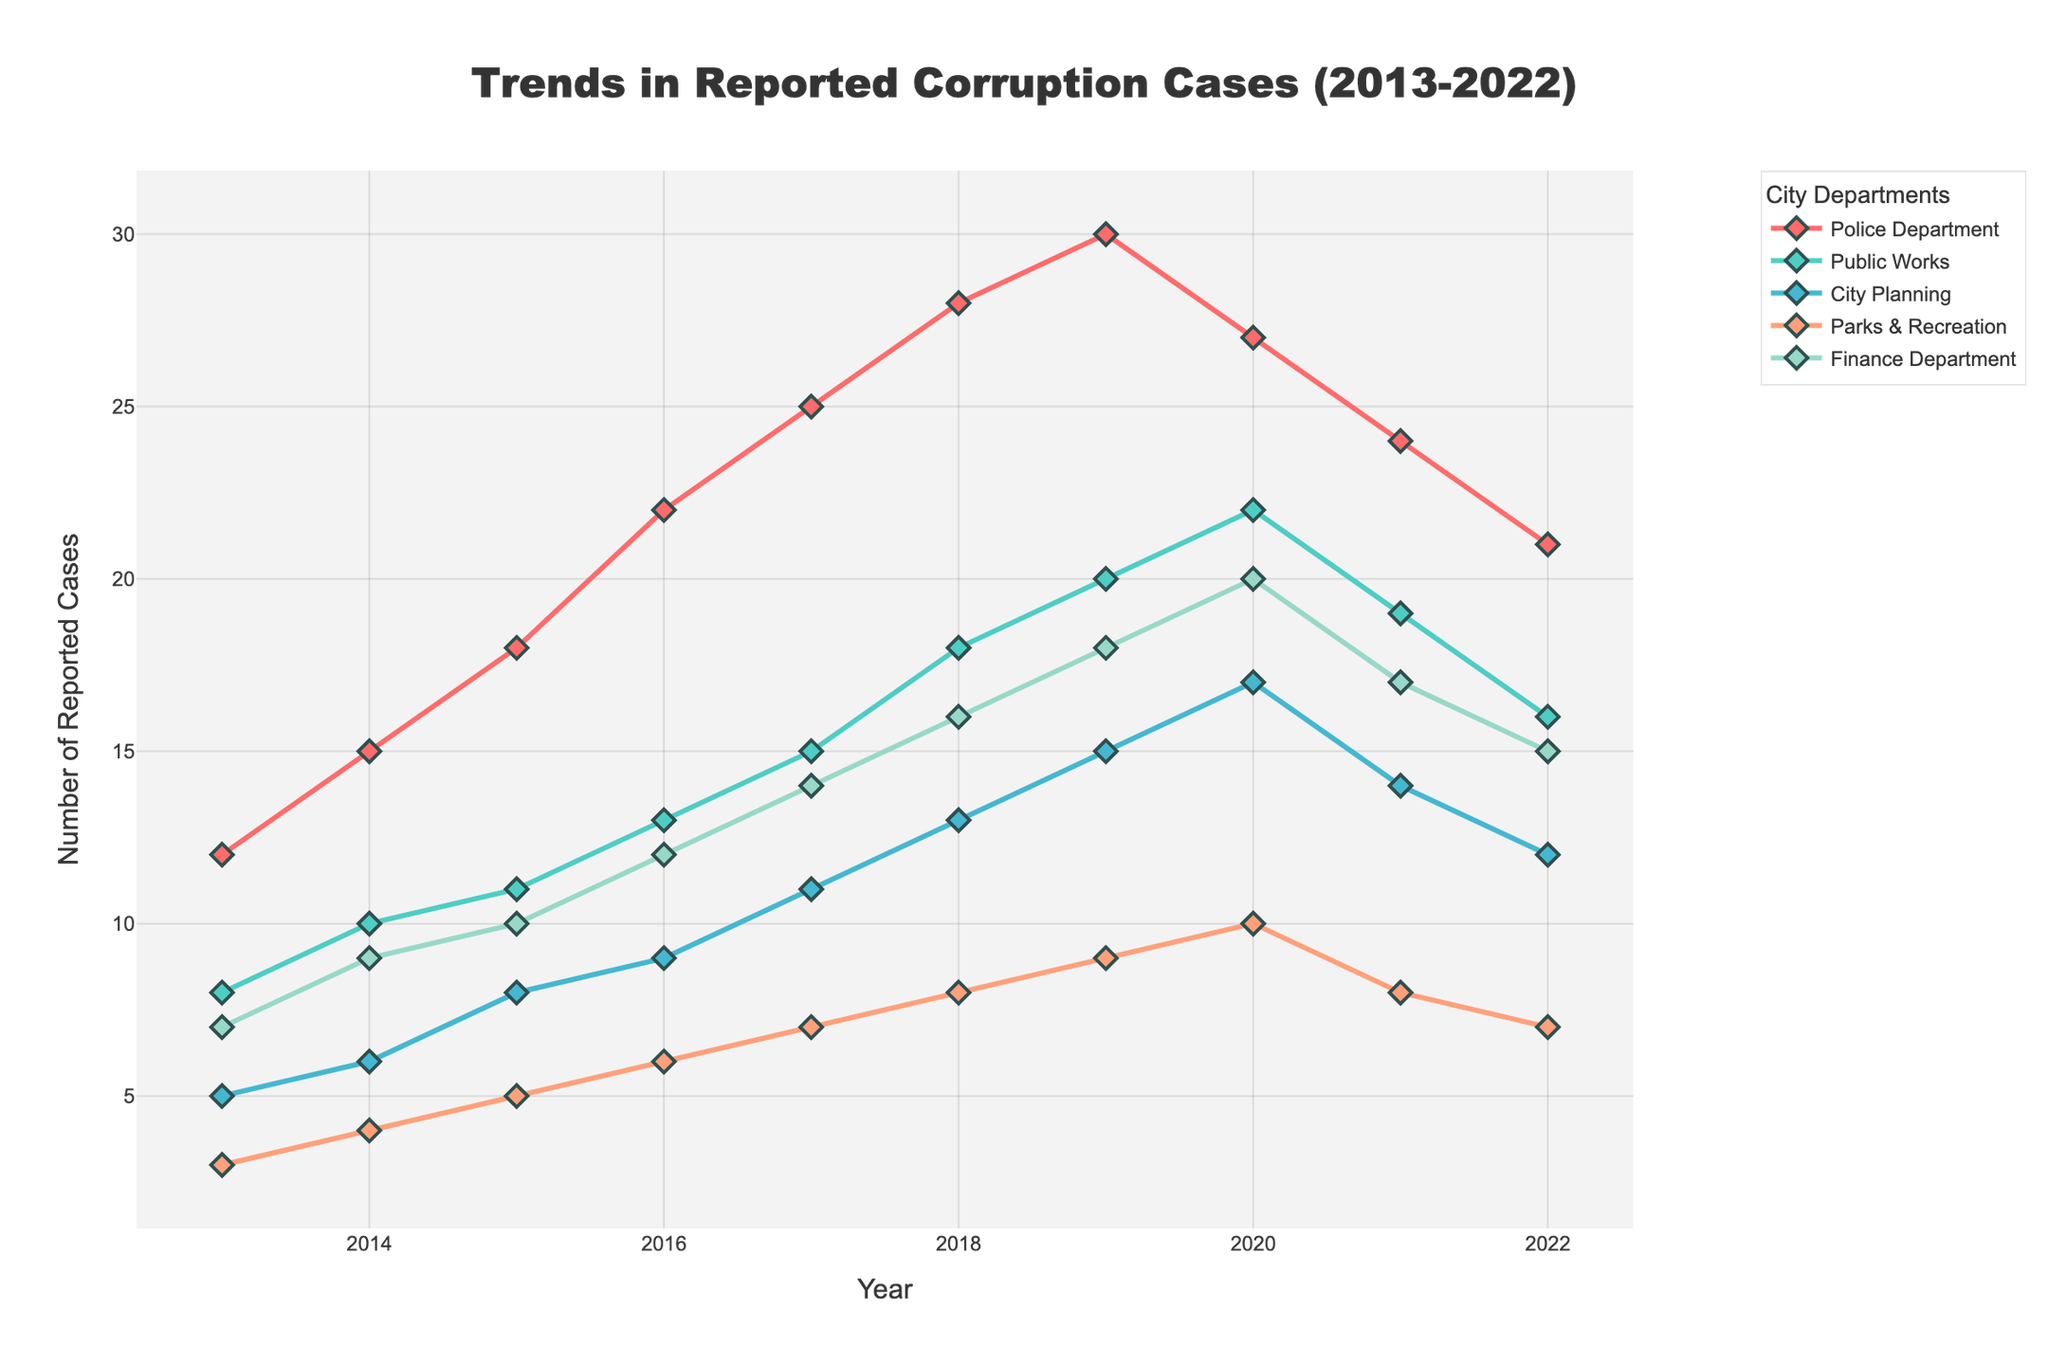How has the trend in corruption cases reported in the Police Department changed from 2013 to 2022? First, we look at the number of reported cases in the Police Department for each year from 2013 to 2022. We observe that the number increases from 12 in 2013 to a peak of 30 in 2019 before declining to 21 in 2022.
Answer: Increased, then decreased In which year did the Finance Department report the highest number of corruption cases? By observing the line for the Finance Department, we notice that the peak value occurs in 2020, with 20 cases reported.
Answer: 2020 Which department showed the most consistent increase in reported corruption cases from 2013 to 2018? To find the most consistent increase, we look at the slopes of the lines for each department from 2013 to 2018. The Police Department line consistently rises each year without any decline or plateau, indicating a constant increase.
Answer: Police Department From 2019 to 2022, which department saw the largest decrease in reported corruption cases? We compare the values of each department between 2019 and 2022. The Police Department decreased from 30 in 2019 to 21 in 2022, a total decrease of 9 cases. This is the largest decrease among the departments.
Answer: Police Department What is the average number of reported corruption cases in the Parks & Recreation Department over the decade from 2013 to 2022? The number of cases in Parks & Recreation for each year is: 3, 4, 5, 6, 7, 8, 9, 10, 8, 7. Summing these gives 67, and dividing by 10 years, the average is 6.7.
Answer: 6.7 Compare the number of corruption cases reported in Public Works in 2014 and City Planning in 2018. Which is higher? In 2014, Public Works reported 10 cases. In 2018, City Planning reported 13 cases. Comparing the two, City Planning in 2018 had a higher number of reported cases.
Answer: City Planning in 2018 What was the total number of corruption cases reported in 2017 across all departments? Summing the values for all departments in 2017: Police Department (25), Public Works (15), City Planning (11), Parks & Recreation (7), Finance Department (14), the total is 72.
Answer: 72 Which year saw the highest number of corruption cases in the Parks & Recreation Department, and what was the number? The line for Parks & Recreation shows a peak in 2020 with 10 reported cases, which is the highest number for this department over the decade.
Answer: 2020, 10 How did the trend in corruption cases reported in the City Planning department change from 2018 to 2022? We observe that in City Planning, the reported cases increase from 13 in 2018 to 15 in 2019, then drop to 12 by 2022. This indicates an initial increase followed by a decrease.
Answer: Increased then decreased 